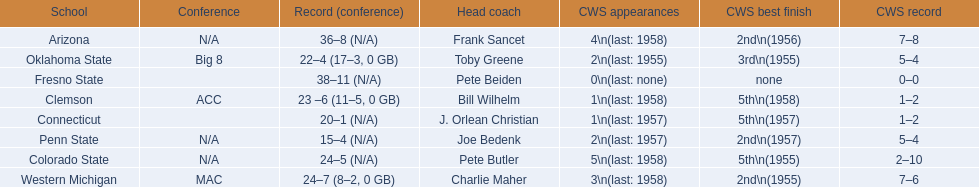Could you help me parse every detail presented in this table? {'header': ['School', 'Conference', 'Record (conference)', 'Head coach', 'CWS appearances', 'CWS best finish', 'CWS record'], 'rows': [['Arizona', 'N/A', '36–8 (N/A)', 'Frank Sancet', '4\\n(last: 1958)', '2nd\\n(1956)', '7–8'], ['Oklahoma State', 'Big 8', '22–4 (17–3, 0 GB)', 'Toby Greene', '2\\n(last: 1955)', '3rd\\n(1955)', '5–4'], ['Fresno State', '', '38–11 (N/A)', 'Pete Beiden', '0\\n(last: none)', 'none', '0–0'], ['Clemson', 'ACC', '23 –6 (11–5, 0 GB)', 'Bill Wilhelm', '1\\n(last: 1958)', '5th\\n(1958)', '1–2'], ['Connecticut', '', '20–1 (N/A)', 'J. Orlean Christian', '1\\n(last: 1957)', '5th\\n(1957)', '1–2'], ['Penn State', 'N/A', '15–4 (N/A)', 'Joe Bedenk', '2\\n(last: 1957)', '2nd\\n(1957)', '5–4'], ['Colorado State', 'N/A', '24–5 (N/A)', 'Pete Butler', '5\\n(last: 1958)', '5th\\n(1955)', '2–10'], ['Western Michigan', 'MAC', '24–7 (8–2, 0 GB)', 'Charlie Maher', '3\\n(last: 1958)', '2nd\\n(1955)', '7–6']]} Which team did not have more than 16 wins? Penn State. 